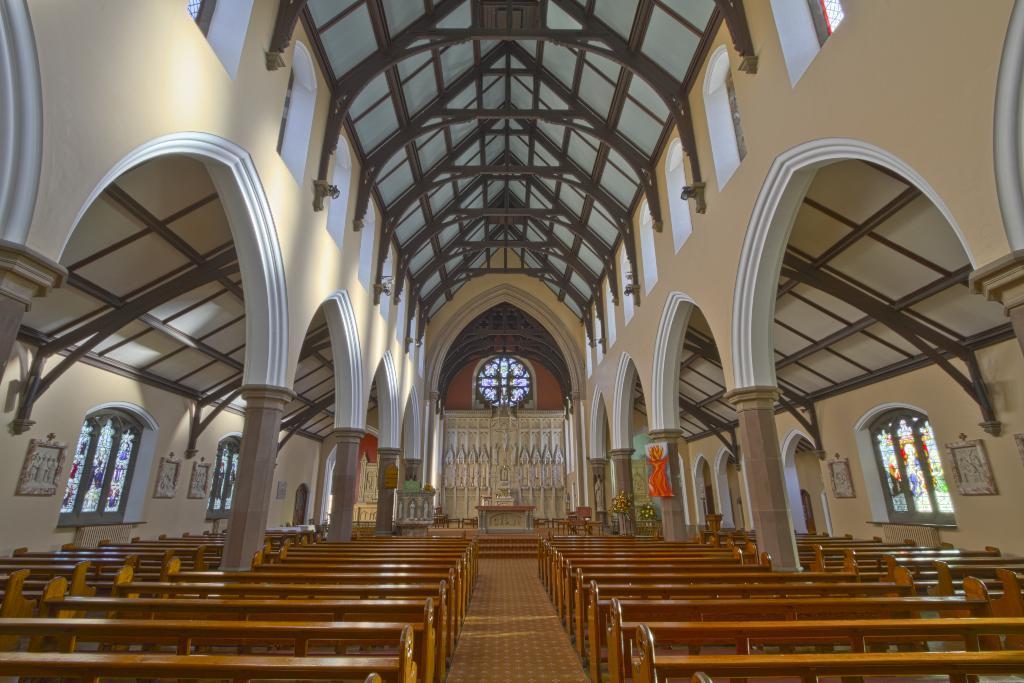In one or two sentences, can you explain what this image depicts? In the picture we can see an interior of the church with two rows of benches and a path in the middle and in the background, we can see a cross with a table structure and besides we can see a pillar and to the walls we can see some windows. 